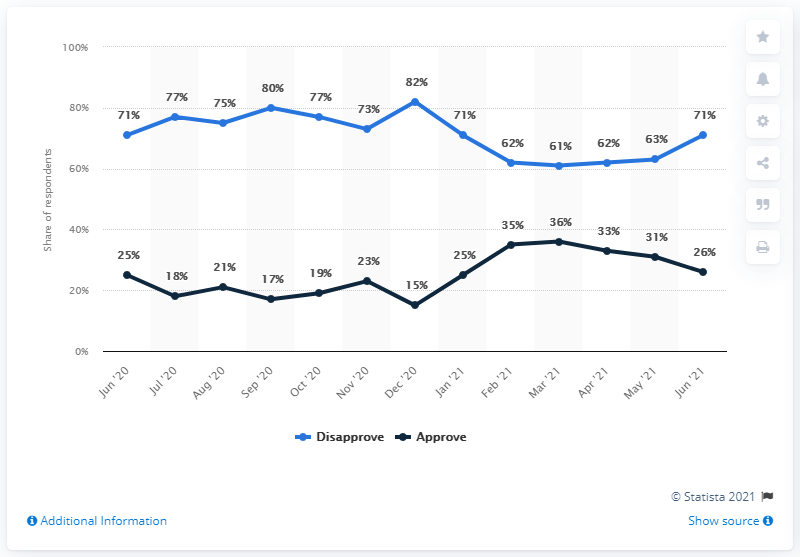Give some essential details in this illustration. In June 2021, the Congressional approval rating was 31%. In March 2021, the two lines were closest to each other in the chart. At the peak of disagreement over Congress's handling of its job in December 2020, there was widespread criticism of the Congress's performance and ineffectiveness in addressing the pressing issues facing the country. 